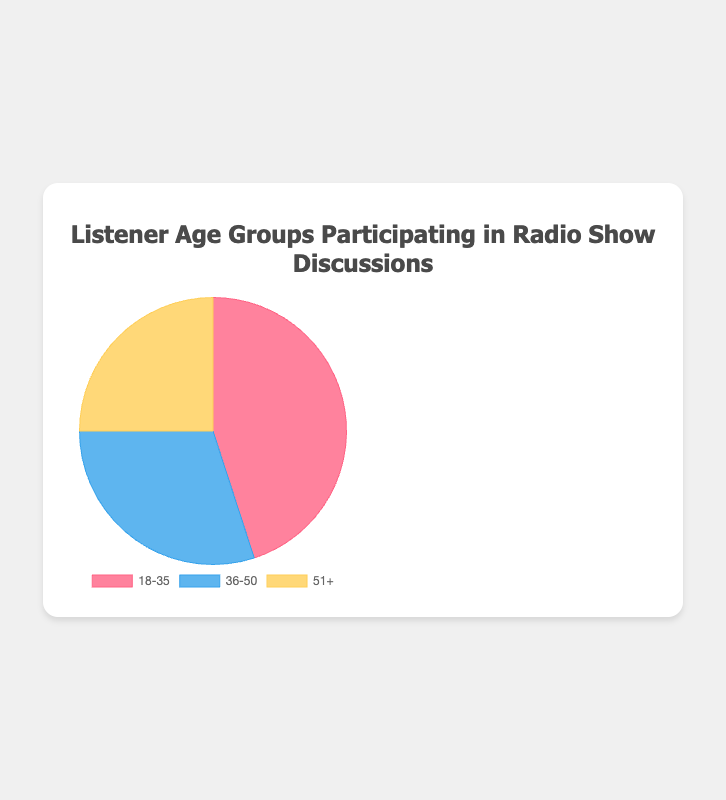Which age group has the highest percentage of participants in radio show discussions? The chart shows that the 18-35 age group has a portion that appears larger than the other age groups, indicating it has the highest percentage.
Answer: 18-35 What is the total percentage for the 36-50 and 51+ age groups combined? To find the combined percentage, sum the percentages of the 36-50 and 51+ age groups: 30% + 25% = 55%.
Answer: 55% How much larger is the percentage of the 18-35 age group compared to the 51+ age group? Subtract the percentage of the 51+ age group from the 18-35 age group: 45% - 25% = 20%.
Answer: 20% Which age group has the smallest percentage of participants? By looking at the chart, the slice representing the 51+ age group is smaller than the others, indicating it has the smallest percentage.
Answer: 51+ What is the average percentage of participants across all age groups? The average percentage is calculated by taking the sum of all percentages and dividing by the number of groups: (45% + 30% + 25%) / 3 = 100% / 3 ≈ 33.33%.
Answer: 33.33% By how much does the percentage of the 18-35 age group exceed the percentage of the 36-50 age group? Subtract the percentage of the 36-50 age group from the 18-35 age group: 45% - 30% = 15%.
Answer: 15% Which color corresponds to the age group with the second highest percentage? The chart shows different colors for each age group. By identifying that 36-50 has the second highest percentage, we look at the color corresponding to this age group, which is blue.
Answer: Blue If the 18-35 age group's percentage increased by 5%, what would the new percentage be, and how would it affect the total percentage? First, add 5% to the 18-35 age group's original percentage: 45% + 5% = 50%. The total percentage then becomes 50% + 30% + 25% = 105%, which would not be possible as it exceeds 100%, suggesting the need for adjustment in other groups.
Answer: 50%, Exceeds 100% Are there any age groups whose combined percentage exceeds the 18-35 age group? Sum the percentages of different pairs of age groups and compare with the 45% of the 18-35 group. The combined percentage of the 36-50 and 51+ age groups is 30% + 25% = 55%, which exceeds 45%.
Answer: Yes, 36-50 & 51+ What portion of the chart is represented by the 36-50 age group visually? Visually, the 36-50 age group occupies 30% of the chart area, which is roughly one-third. The chart depicts different sections where each slice size is proportional to the percentage value.
Answer: Approximately one-third 